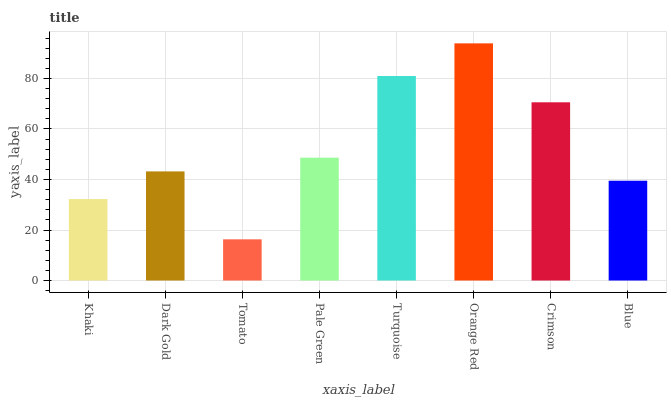Is Tomato the minimum?
Answer yes or no. Yes. Is Orange Red the maximum?
Answer yes or no. Yes. Is Dark Gold the minimum?
Answer yes or no. No. Is Dark Gold the maximum?
Answer yes or no. No. Is Dark Gold greater than Khaki?
Answer yes or no. Yes. Is Khaki less than Dark Gold?
Answer yes or no. Yes. Is Khaki greater than Dark Gold?
Answer yes or no. No. Is Dark Gold less than Khaki?
Answer yes or no. No. Is Pale Green the high median?
Answer yes or no. Yes. Is Dark Gold the low median?
Answer yes or no. Yes. Is Blue the high median?
Answer yes or no. No. Is Turquoise the low median?
Answer yes or no. No. 